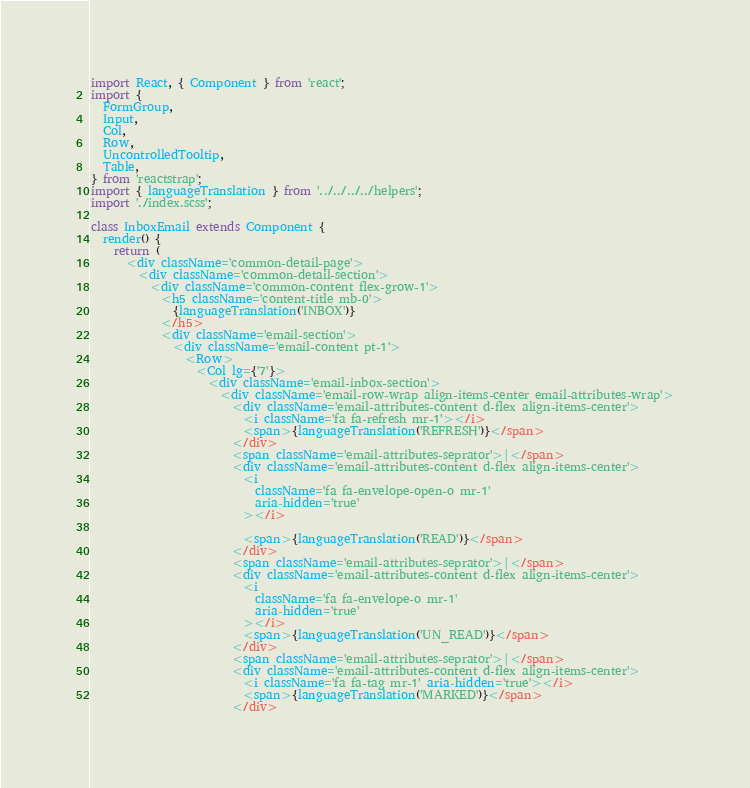Convert code to text. <code><loc_0><loc_0><loc_500><loc_500><_TypeScript_>import React, { Component } from 'react';
import {
  FormGroup,
  Input,
  Col,
  Row,
  UncontrolledTooltip,
  Table,
} from 'reactstrap';
import { languageTranslation } from '../../../../helpers';
import './index.scss';

class InboxEmail extends Component {
  render() {
    return (
      <div className='common-detail-page'>
        <div className='common-detail-section'>
          <div className='common-content flex-grow-1'>
            <h5 className='content-title mb-0'>
              {languageTranslation('INBOX')}
            </h5>
            <div className='email-section'>
              <div className='email-content pt-1'>
                <Row>
                  <Col lg={'7'}>
                    <div className='email-inbox-section'>
                      <div className='email-row-wrap align-items-center email-attributes-wrap'>
                        <div className='email-attributes-content d-flex align-items-center'>
                          <i className='fa fa-refresh mr-1'></i>
                          <span>{languageTranslation('REFRESH')}</span>
                        </div>
                        <span className='email-attributes-seprator'>|</span>
                        <div className='email-attributes-content d-flex align-items-center'>
                          <i
                            className='fa fa-envelope-open-o mr-1'
                            aria-hidden='true'
                          ></i>

                          <span>{languageTranslation('READ')}</span>
                        </div>
                        <span className='email-attributes-seprator'>|</span>
                        <div className='email-attributes-content d-flex align-items-center'>
                          <i
                            className='fa fa-envelope-o mr-1'
                            aria-hidden='true'
                          ></i>
                          <span>{languageTranslation('UN_READ')}</span>
                        </div>
                        <span className='email-attributes-seprator'>|</span>
                        <div className='email-attributes-content d-flex align-items-center'>
                          <i className='fa fa-tag mr-1' aria-hidden='true'></i>
                          <span>{languageTranslation('MARKED')}</span>
                        </div></code> 